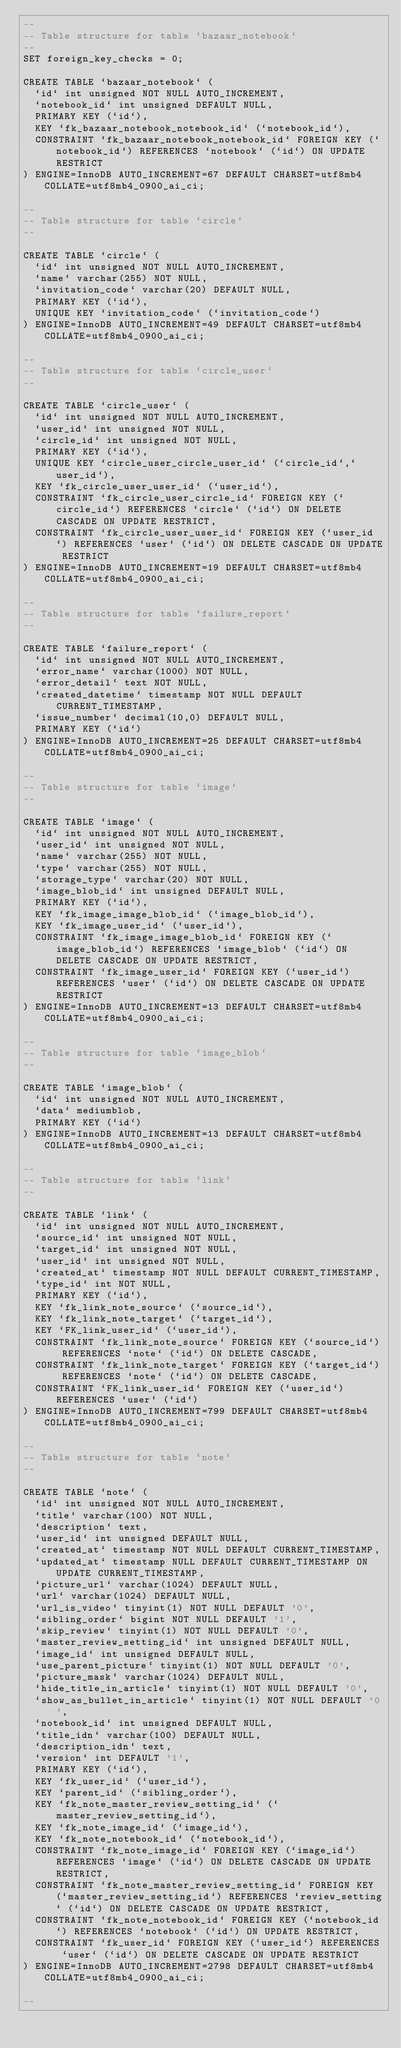<code> <loc_0><loc_0><loc_500><loc_500><_SQL_>--
-- Table structure for table `bazaar_notebook`
--
SET foreign_key_checks = 0;

CREATE TABLE `bazaar_notebook` (
  `id` int unsigned NOT NULL AUTO_INCREMENT,
  `notebook_id` int unsigned DEFAULT NULL,
  PRIMARY KEY (`id`),
  KEY `fk_bazaar_notebook_notebook_id` (`notebook_id`),
  CONSTRAINT `fk_bazaar_notebook_notebook_id` FOREIGN KEY (`notebook_id`) REFERENCES `notebook` (`id`) ON UPDATE RESTRICT
) ENGINE=InnoDB AUTO_INCREMENT=67 DEFAULT CHARSET=utf8mb4 COLLATE=utf8mb4_0900_ai_ci;

--
-- Table structure for table `circle`
--

CREATE TABLE `circle` (
  `id` int unsigned NOT NULL AUTO_INCREMENT,
  `name` varchar(255) NOT NULL,
  `invitation_code` varchar(20) DEFAULT NULL,
  PRIMARY KEY (`id`),
  UNIQUE KEY `invitation_code` (`invitation_code`)
) ENGINE=InnoDB AUTO_INCREMENT=49 DEFAULT CHARSET=utf8mb4 COLLATE=utf8mb4_0900_ai_ci;

--
-- Table structure for table `circle_user`
--

CREATE TABLE `circle_user` (
  `id` int unsigned NOT NULL AUTO_INCREMENT,
  `user_id` int unsigned NOT NULL,
  `circle_id` int unsigned NOT NULL,
  PRIMARY KEY (`id`),
  UNIQUE KEY `circle_user_circle_user_id` (`circle_id`,`user_id`),
  KEY `fk_circle_user_user_id` (`user_id`),
  CONSTRAINT `fk_circle_user_circle_id` FOREIGN KEY (`circle_id`) REFERENCES `circle` (`id`) ON DELETE CASCADE ON UPDATE RESTRICT,
  CONSTRAINT `fk_circle_user_user_id` FOREIGN KEY (`user_id`) REFERENCES `user` (`id`) ON DELETE CASCADE ON UPDATE RESTRICT
) ENGINE=InnoDB AUTO_INCREMENT=19 DEFAULT CHARSET=utf8mb4 COLLATE=utf8mb4_0900_ai_ci;

--
-- Table structure for table `failure_report`
--

CREATE TABLE `failure_report` (
  `id` int unsigned NOT NULL AUTO_INCREMENT,
  `error_name` varchar(1000) NOT NULL,
  `error_detail` text NOT NULL,
  `created_datetime` timestamp NOT NULL DEFAULT CURRENT_TIMESTAMP,
  `issue_number` decimal(10,0) DEFAULT NULL,
  PRIMARY KEY (`id`)
) ENGINE=InnoDB AUTO_INCREMENT=25 DEFAULT CHARSET=utf8mb4 COLLATE=utf8mb4_0900_ai_ci;

--
-- Table structure for table `image`
--

CREATE TABLE `image` (
  `id` int unsigned NOT NULL AUTO_INCREMENT,
  `user_id` int unsigned NOT NULL,
  `name` varchar(255) NOT NULL,
  `type` varchar(255) NOT NULL,
  `storage_type` varchar(20) NOT NULL,
  `image_blob_id` int unsigned DEFAULT NULL,
  PRIMARY KEY (`id`),
  KEY `fk_image_image_blob_id` (`image_blob_id`),
  KEY `fk_image_user_id` (`user_id`),
  CONSTRAINT `fk_image_image_blob_id` FOREIGN KEY (`image_blob_id`) REFERENCES `image_blob` (`id`) ON DELETE CASCADE ON UPDATE RESTRICT,
  CONSTRAINT `fk_image_user_id` FOREIGN KEY (`user_id`) REFERENCES `user` (`id`) ON DELETE CASCADE ON UPDATE RESTRICT
) ENGINE=InnoDB AUTO_INCREMENT=13 DEFAULT CHARSET=utf8mb4 COLLATE=utf8mb4_0900_ai_ci;

--
-- Table structure for table `image_blob`
--

CREATE TABLE `image_blob` (
  `id` int unsigned NOT NULL AUTO_INCREMENT,
  `data` mediumblob,
  PRIMARY KEY (`id`)
) ENGINE=InnoDB AUTO_INCREMENT=13 DEFAULT CHARSET=utf8mb4 COLLATE=utf8mb4_0900_ai_ci;

--
-- Table structure for table `link`
--

CREATE TABLE `link` (
  `id` int unsigned NOT NULL AUTO_INCREMENT,
  `source_id` int unsigned NOT NULL,
  `target_id` int unsigned NOT NULL,
  `user_id` int unsigned NOT NULL,
  `created_at` timestamp NOT NULL DEFAULT CURRENT_TIMESTAMP,
  `type_id` int NOT NULL,
  PRIMARY KEY (`id`),
  KEY `fk_link_note_source` (`source_id`),
  KEY `fk_link_note_target` (`target_id`),
  KEY `FK_link_user_id` (`user_id`),
  CONSTRAINT `fk_link_note_source` FOREIGN KEY (`source_id`) REFERENCES `note` (`id`) ON DELETE CASCADE,
  CONSTRAINT `fk_link_note_target` FOREIGN KEY (`target_id`) REFERENCES `note` (`id`) ON DELETE CASCADE,
  CONSTRAINT `FK_link_user_id` FOREIGN KEY (`user_id`) REFERENCES `user` (`id`)
) ENGINE=InnoDB AUTO_INCREMENT=799 DEFAULT CHARSET=utf8mb4 COLLATE=utf8mb4_0900_ai_ci;

--
-- Table structure for table `note`
--

CREATE TABLE `note` (
  `id` int unsigned NOT NULL AUTO_INCREMENT,
  `title` varchar(100) NOT NULL,
  `description` text,
  `user_id` int unsigned DEFAULT NULL,
  `created_at` timestamp NOT NULL DEFAULT CURRENT_TIMESTAMP,
  `updated_at` timestamp NULL DEFAULT CURRENT_TIMESTAMP ON UPDATE CURRENT_TIMESTAMP,
  `picture_url` varchar(1024) DEFAULT NULL,
  `url` varchar(1024) DEFAULT NULL,
  `url_is_video` tinyint(1) NOT NULL DEFAULT '0',
  `sibling_order` bigint NOT NULL DEFAULT '1',
  `skip_review` tinyint(1) NOT NULL DEFAULT '0',
  `master_review_setting_id` int unsigned DEFAULT NULL,
  `image_id` int unsigned DEFAULT NULL,
  `use_parent_picture` tinyint(1) NOT NULL DEFAULT '0',
  `picture_mask` varchar(1024) DEFAULT NULL,
  `hide_title_in_article` tinyint(1) NOT NULL DEFAULT '0',
  `show_as_bullet_in_article` tinyint(1) NOT NULL DEFAULT '0',
  `notebook_id` int unsigned DEFAULT NULL,
  `title_idn` varchar(100) DEFAULT NULL,
  `description_idn` text,
  `version` int DEFAULT '1',
  PRIMARY KEY (`id`),
  KEY `fk_user_id` (`user_id`),
  KEY `parent_id` (`sibling_order`),
  KEY `fk_note_master_review_setting_id` (`master_review_setting_id`),
  KEY `fk_note_image_id` (`image_id`),
  KEY `fk_note_notebook_id` (`notebook_id`),
  CONSTRAINT `fk_note_image_id` FOREIGN KEY (`image_id`) REFERENCES `image` (`id`) ON DELETE CASCADE ON UPDATE RESTRICT,
  CONSTRAINT `fk_note_master_review_setting_id` FOREIGN KEY (`master_review_setting_id`) REFERENCES `review_setting` (`id`) ON DELETE CASCADE ON UPDATE RESTRICT,
  CONSTRAINT `fk_note_notebook_id` FOREIGN KEY (`notebook_id`) REFERENCES `notebook` (`id`) ON UPDATE RESTRICT,
  CONSTRAINT `fk_user_id` FOREIGN KEY (`user_id`) REFERENCES `user` (`id`) ON DELETE CASCADE ON UPDATE RESTRICT
) ENGINE=InnoDB AUTO_INCREMENT=2798 DEFAULT CHARSET=utf8mb4 COLLATE=utf8mb4_0900_ai_ci;

--</code> 